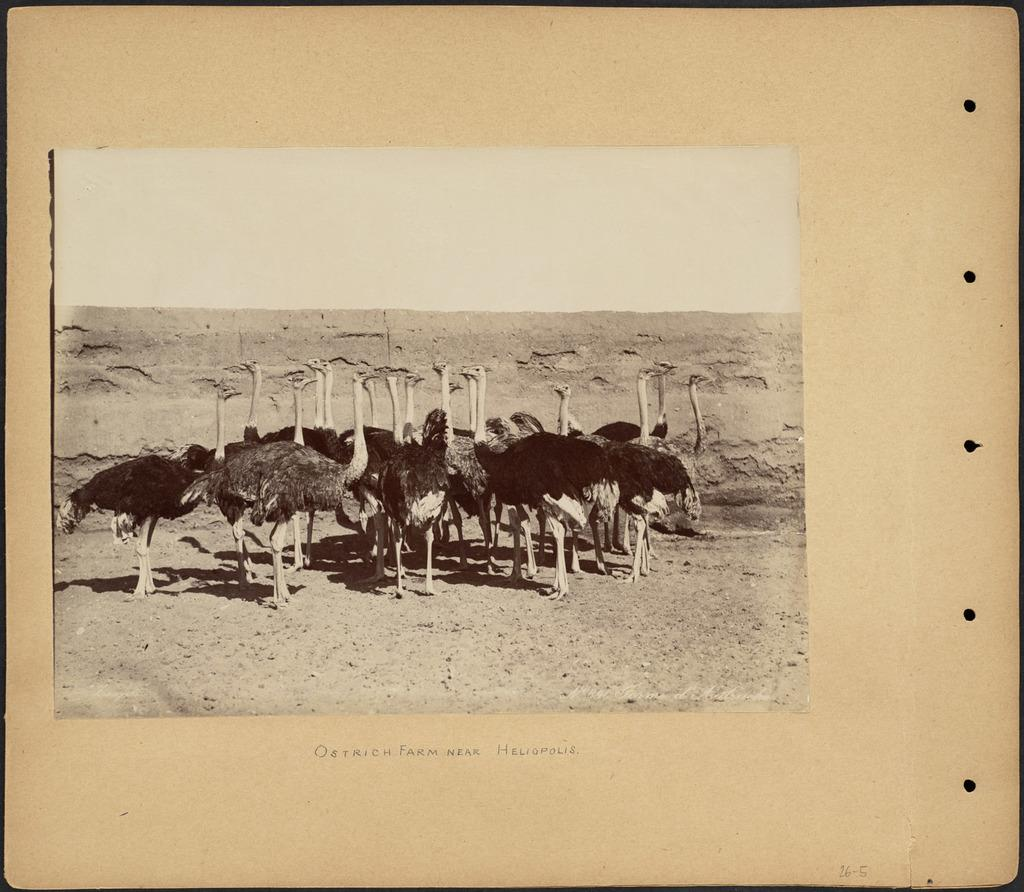What is inside the book that is visible in the image? There is a photo in the book. What animals are featured in the photo? The photo contains ostriches. Where are the ostriches located in the photo? The ostriches are standing on the ground. What type of event is happening in the jail in the image? There is no jail or event present in the image; it features a photo of ostriches standing on the ground. 